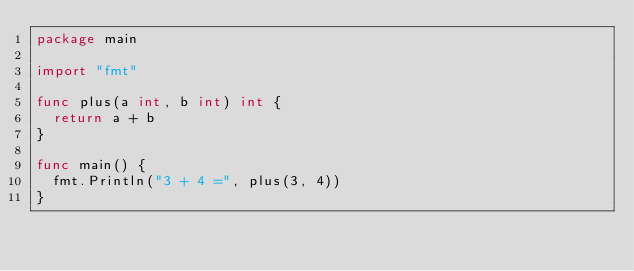<code> <loc_0><loc_0><loc_500><loc_500><_Go_>package main

import "fmt"

func plus(a int, b int) int {
	return a + b
}

func main() {
	fmt.Println("3 + 4 =", plus(3, 4))
}
</code> 